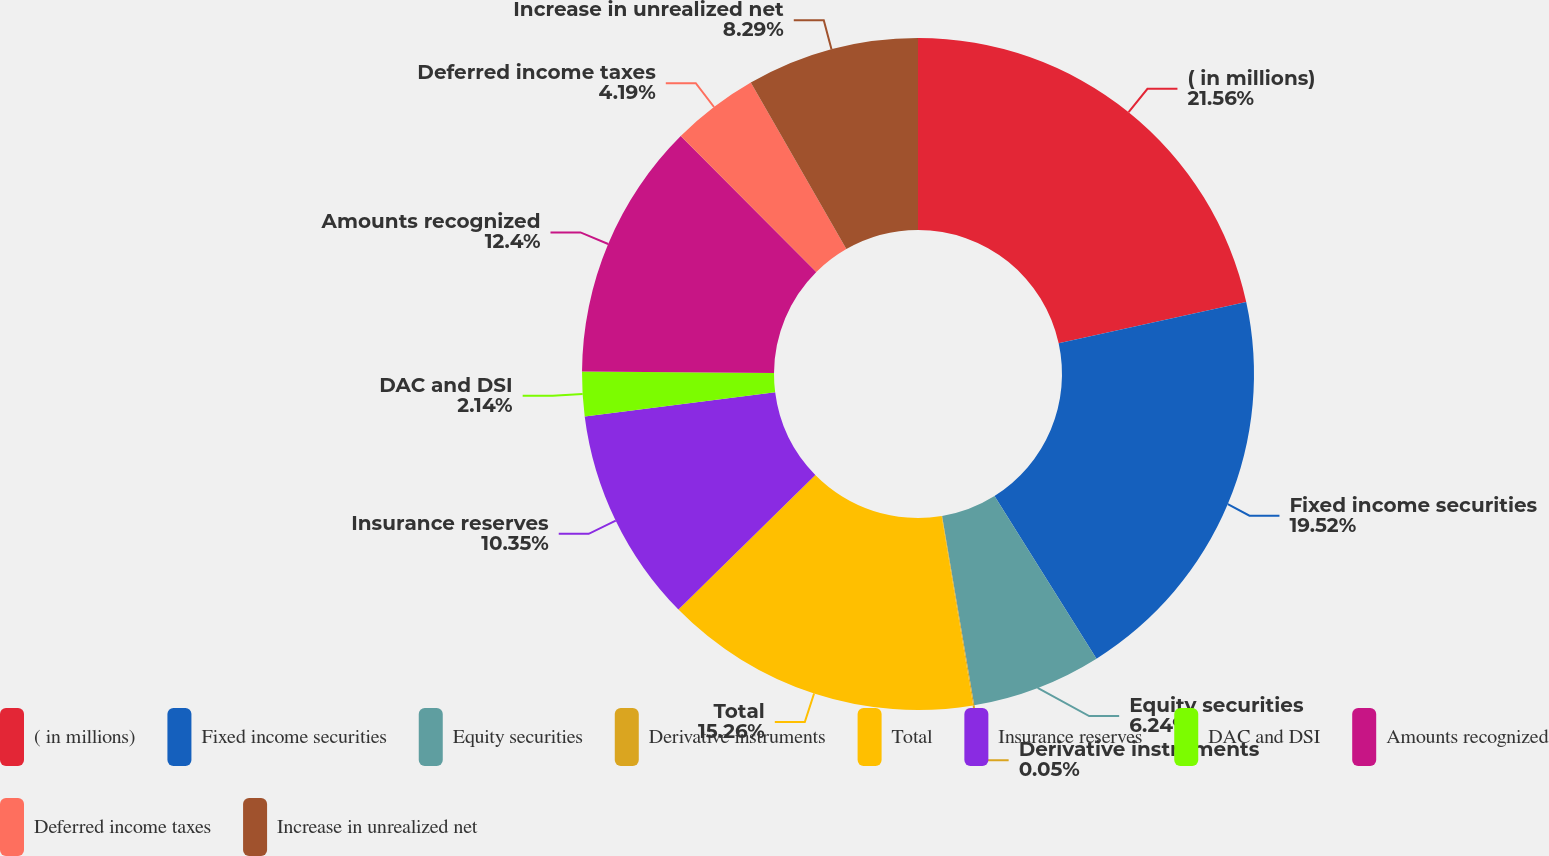Convert chart. <chart><loc_0><loc_0><loc_500><loc_500><pie_chart><fcel>( in millions)<fcel>Fixed income securities<fcel>Equity securities<fcel>Derivative instruments<fcel>Total<fcel>Insurance reserves<fcel>DAC and DSI<fcel>Amounts recognized<fcel>Deferred income taxes<fcel>Increase in unrealized net<nl><fcel>21.57%<fcel>19.52%<fcel>6.24%<fcel>0.05%<fcel>15.26%<fcel>10.35%<fcel>2.14%<fcel>12.4%<fcel>4.19%<fcel>8.29%<nl></chart> 